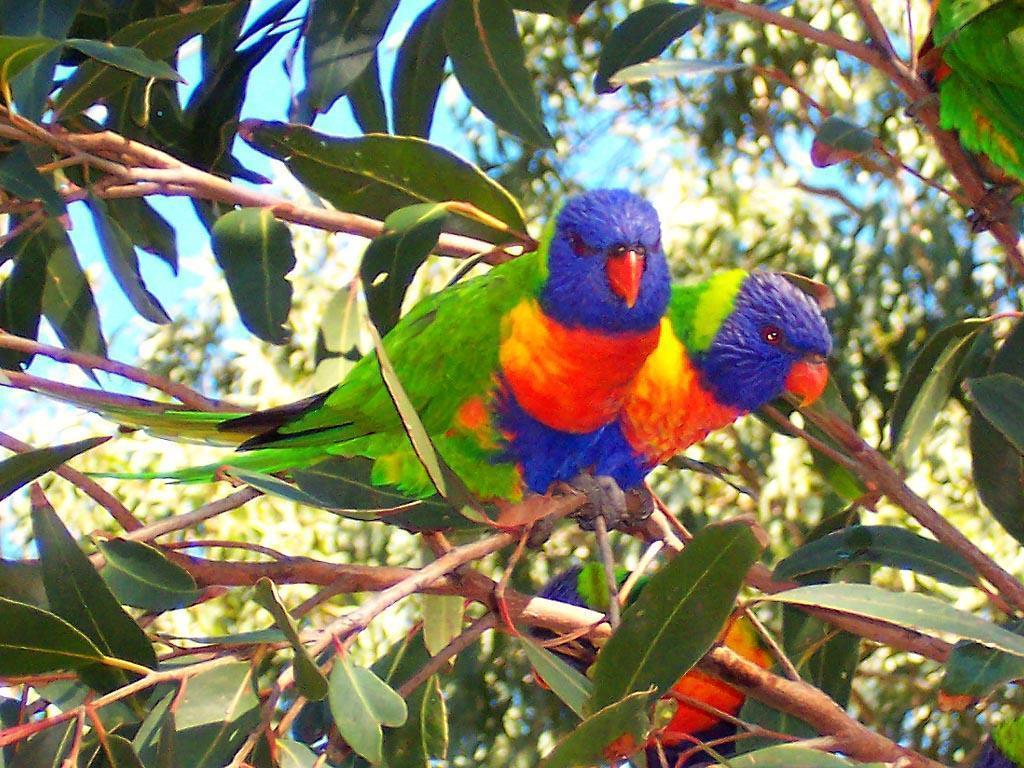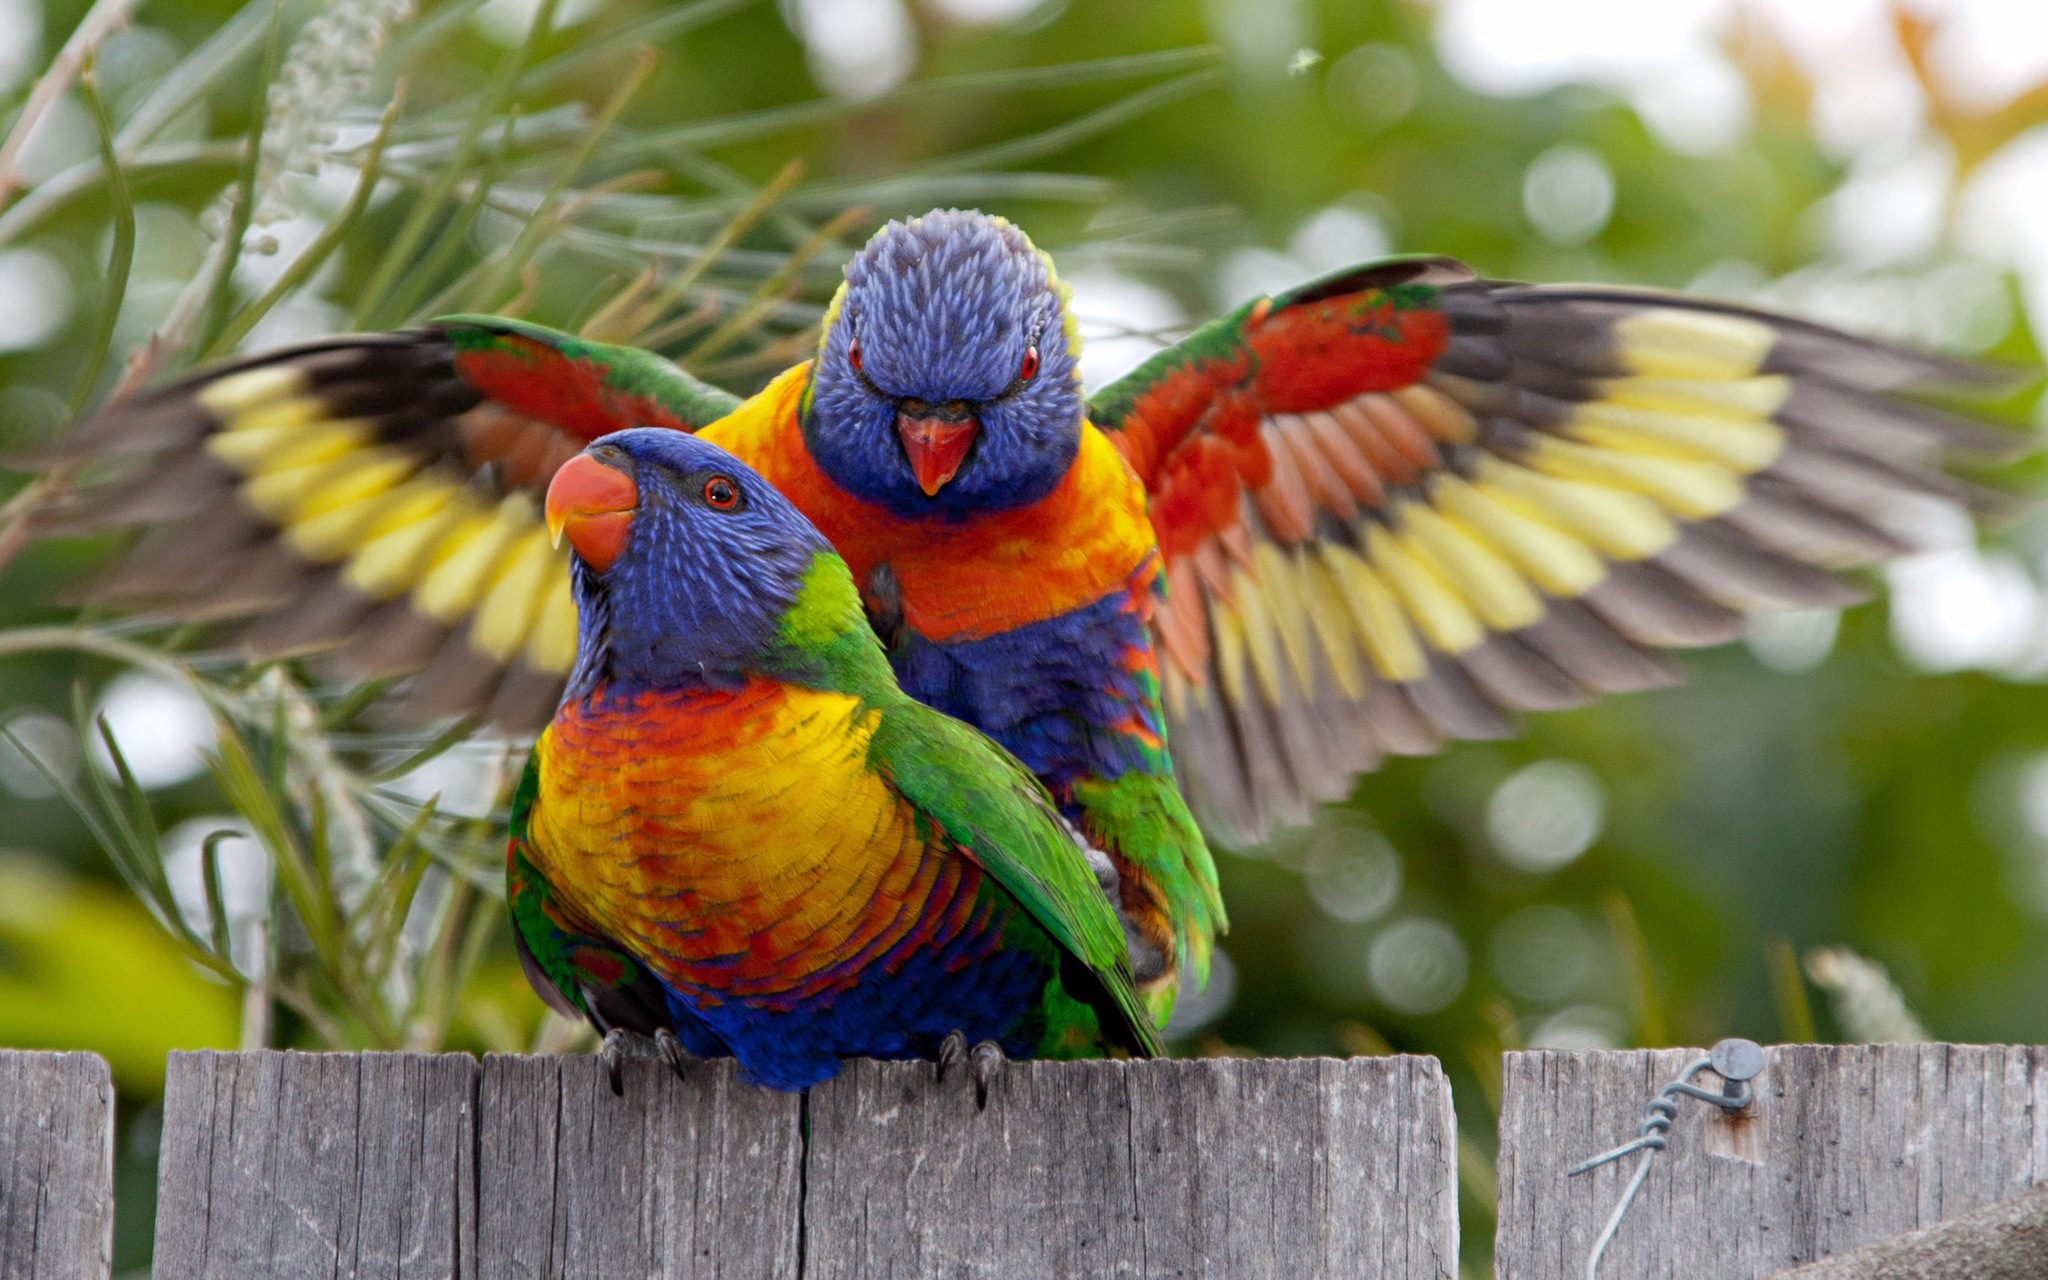The first image is the image on the left, the second image is the image on the right. Evaluate the accuracy of this statement regarding the images: "There are exactly three birds in the image on the right.". Is it true? Answer yes or no. No. 